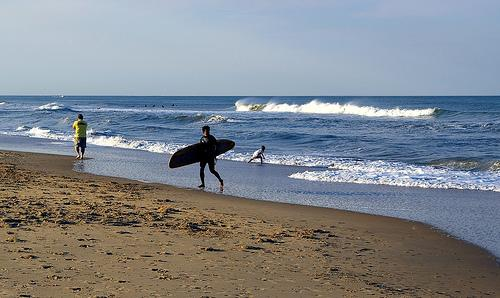Why is the small child in the water? Please explain your reasoning. enjoys playing. This child's bent over stance with one foot in the air suggests he is playing in the waves and surf. 